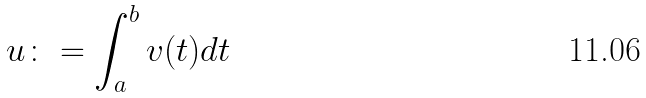<formula> <loc_0><loc_0><loc_500><loc_500>u \colon = \int _ { a } ^ { b } v ( t ) d t</formula> 